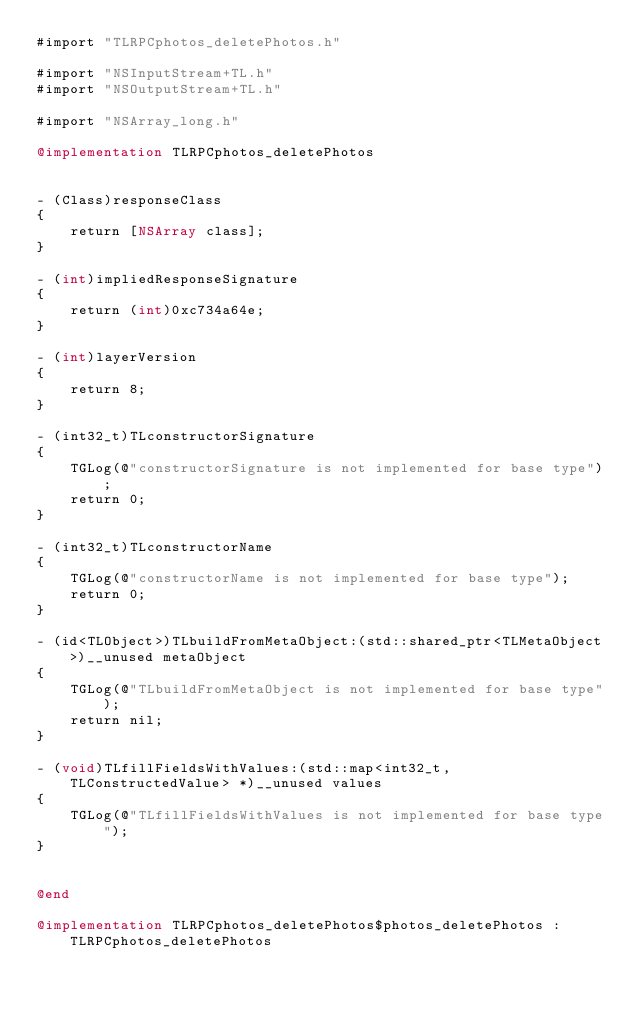Convert code to text. <code><loc_0><loc_0><loc_500><loc_500><_ObjectiveC_>#import "TLRPCphotos_deletePhotos.h"

#import "NSInputStream+TL.h"
#import "NSOutputStream+TL.h"

#import "NSArray_long.h"

@implementation TLRPCphotos_deletePhotos


- (Class)responseClass
{
    return [NSArray class];
}

- (int)impliedResponseSignature
{
    return (int)0xc734a64e;
}

- (int)layerVersion
{
    return 8;
}

- (int32_t)TLconstructorSignature
{
    TGLog(@"constructorSignature is not implemented for base type");
    return 0;
}

- (int32_t)TLconstructorName
{
    TGLog(@"constructorName is not implemented for base type");
    return 0;
}

- (id<TLObject>)TLbuildFromMetaObject:(std::shared_ptr<TLMetaObject>)__unused metaObject
{
    TGLog(@"TLbuildFromMetaObject is not implemented for base type");
    return nil;
}

- (void)TLfillFieldsWithValues:(std::map<int32_t, TLConstructedValue> *)__unused values
{
    TGLog(@"TLfillFieldsWithValues is not implemented for base type");
}


@end

@implementation TLRPCphotos_deletePhotos$photos_deletePhotos : TLRPCphotos_deletePhotos

</code> 